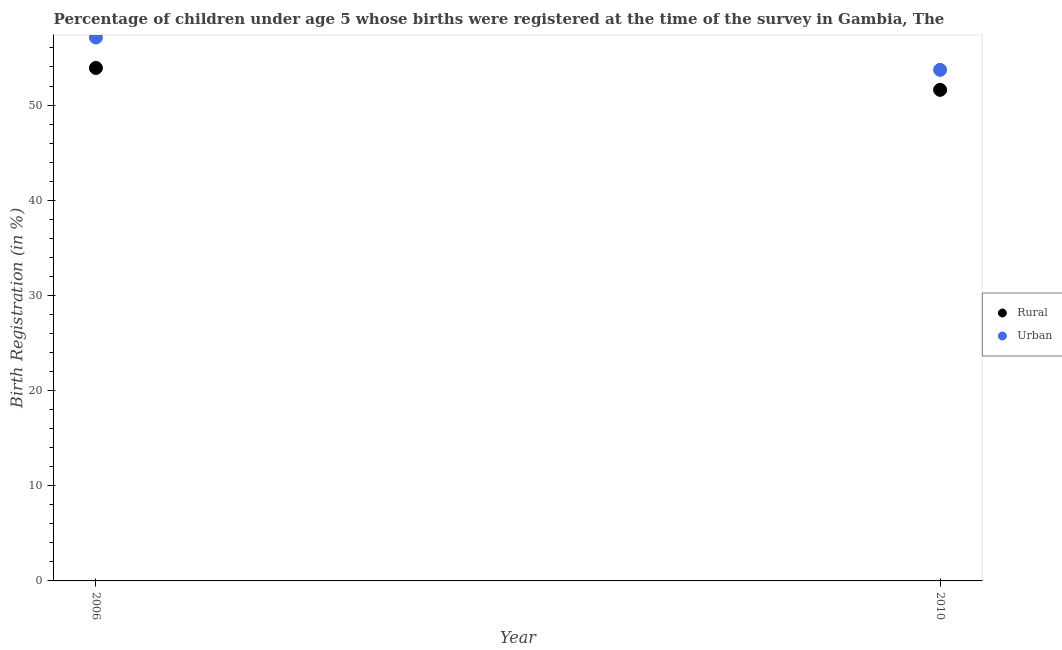Is the number of dotlines equal to the number of legend labels?
Ensure brevity in your answer.  Yes. What is the urban birth registration in 2010?
Keep it short and to the point. 53.7. Across all years, what is the maximum rural birth registration?
Make the answer very short. 53.9. Across all years, what is the minimum rural birth registration?
Your answer should be very brief. 51.6. In which year was the rural birth registration minimum?
Make the answer very short. 2010. What is the total urban birth registration in the graph?
Keep it short and to the point. 110.8. What is the difference between the rural birth registration in 2006 and that in 2010?
Offer a very short reply. 2.3. What is the difference between the urban birth registration in 2010 and the rural birth registration in 2006?
Make the answer very short. -0.2. What is the average urban birth registration per year?
Offer a terse response. 55.4. In the year 2010, what is the difference between the rural birth registration and urban birth registration?
Your answer should be very brief. -2.1. What is the ratio of the rural birth registration in 2006 to that in 2010?
Provide a succinct answer. 1.04. In how many years, is the urban birth registration greater than the average urban birth registration taken over all years?
Your answer should be compact. 1. Does the urban birth registration monotonically increase over the years?
Offer a very short reply. No. Is the rural birth registration strictly greater than the urban birth registration over the years?
Offer a very short reply. No. How many years are there in the graph?
Make the answer very short. 2. Are the values on the major ticks of Y-axis written in scientific E-notation?
Your answer should be compact. No. Does the graph contain any zero values?
Keep it short and to the point. No. How many legend labels are there?
Your response must be concise. 2. What is the title of the graph?
Your response must be concise. Percentage of children under age 5 whose births were registered at the time of the survey in Gambia, The. Does "Subsidies" appear as one of the legend labels in the graph?
Your answer should be very brief. No. What is the label or title of the X-axis?
Ensure brevity in your answer.  Year. What is the label or title of the Y-axis?
Your response must be concise. Birth Registration (in %). What is the Birth Registration (in %) in Rural in 2006?
Provide a short and direct response. 53.9. What is the Birth Registration (in %) in Urban in 2006?
Offer a very short reply. 57.1. What is the Birth Registration (in %) of Rural in 2010?
Provide a short and direct response. 51.6. What is the Birth Registration (in %) in Urban in 2010?
Your answer should be compact. 53.7. Across all years, what is the maximum Birth Registration (in %) in Rural?
Make the answer very short. 53.9. Across all years, what is the maximum Birth Registration (in %) in Urban?
Your answer should be very brief. 57.1. Across all years, what is the minimum Birth Registration (in %) of Rural?
Provide a short and direct response. 51.6. Across all years, what is the minimum Birth Registration (in %) in Urban?
Provide a succinct answer. 53.7. What is the total Birth Registration (in %) in Rural in the graph?
Offer a terse response. 105.5. What is the total Birth Registration (in %) in Urban in the graph?
Make the answer very short. 110.8. What is the difference between the Birth Registration (in %) in Rural in 2006 and the Birth Registration (in %) in Urban in 2010?
Your response must be concise. 0.2. What is the average Birth Registration (in %) in Rural per year?
Your answer should be very brief. 52.75. What is the average Birth Registration (in %) in Urban per year?
Offer a very short reply. 55.4. In the year 2006, what is the difference between the Birth Registration (in %) of Rural and Birth Registration (in %) of Urban?
Your answer should be very brief. -3.2. What is the ratio of the Birth Registration (in %) in Rural in 2006 to that in 2010?
Your response must be concise. 1.04. What is the ratio of the Birth Registration (in %) in Urban in 2006 to that in 2010?
Provide a short and direct response. 1.06. What is the difference between the highest and the second highest Birth Registration (in %) of Rural?
Your answer should be compact. 2.3. What is the difference between the highest and the second highest Birth Registration (in %) of Urban?
Keep it short and to the point. 3.4. 